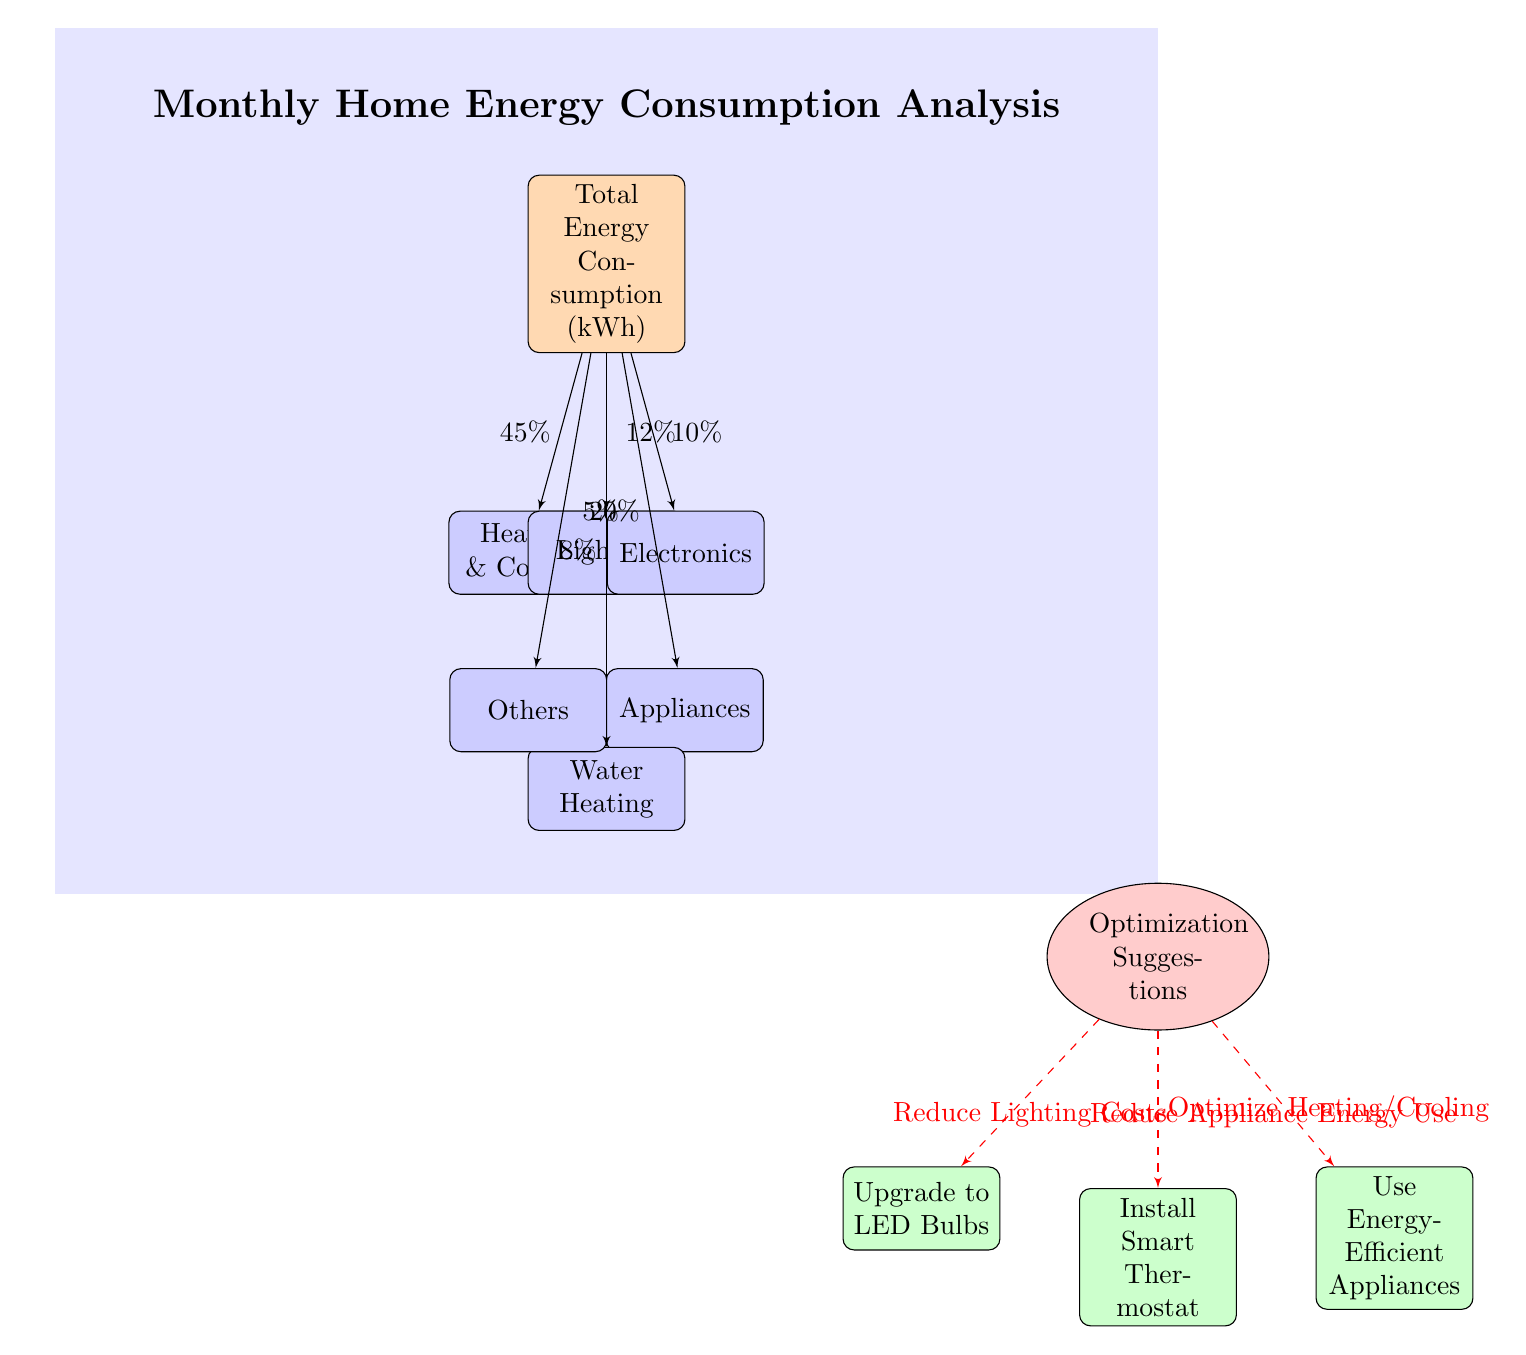What is the total energy consumption percentage attributed to Heating & Cooling? The diagram indicates that Heating & Cooling accounts for approximately 45% of the total energy consumption node, as shown by the flow from the total energy consumption box to the Heating & Cooling box.
Answer: 45% How many categories of energy consumption are displayed in the diagram? The diagram lists six categories of energy consumption: Heating & Cooling, Lighting, Electronics, Appliances, Water Heating, and Others. Therefore, there are a total of six categories present.
Answer: 6 What optimization suggestion corresponds to reducing appliance energy use? The diagram suggests using Energy-Efficient Appliances as a way to reduce appliance energy usage. This is connected to the Optimization Suggestions cloud, showing its specific link to appliances.
Answer: Use Energy-Efficient Appliances Which category has the lowest energy consumption percentage? According to the diagram, the category with the lowest percentage is Others, which is indicated to account for approximately 5% of the total energy consumption displayed.
Answer: 5% What percentage of total energy consumption does Water Heating represent? The Water Heating category is shown in the diagram as accounting for about 8% of the total energy consumption, based on the percentage indicated on the line connecting the total node to the Water Heating block.
Answer: 8% Which optimization suggestion is aimed at optimizing heating and cooling? The optimization suggestion that targets improving Heating & Cooling is Installing a Smart Thermostat, as indicated by the connection from the optimization suggestions cloud to the corresponding box.
Answer: Install Smart Thermostat What is the total percentage represented by Appliances? The Appliances category shows a percentage of around 20% in the diagram, as indicated by the flow from the total energy consumption node to the Appliances block.
Answer: 20% 